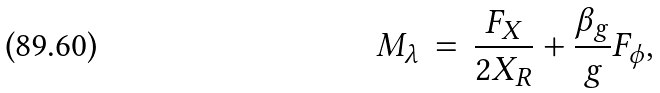Convert formula to latex. <formula><loc_0><loc_0><loc_500><loc_500>M _ { \lambda } \, = \, \frac { F _ { X } } { 2 X _ { R } } + \frac { \beta _ { g } } { g } F _ { \phi } ,</formula> 